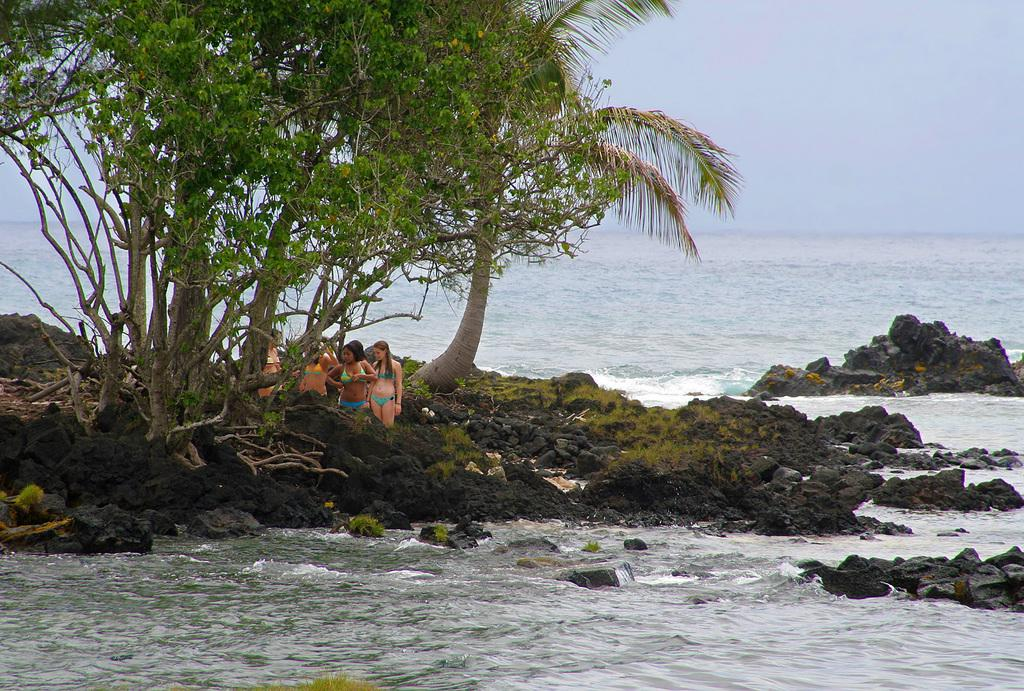What is the primary element visible in the image? There is water in the image. What other natural elements can be seen in the image? There are rocks and trees visible in the image. Are there any people present in the image? Yes, there is a group of people in the image. What is visible at the top of the image? The sky is visible at the top of the image. Can you tell me how many horses are in the image? There are no horses present in the image. What type of animal can be seen interacting with the people in the image? There are no animals visible in the image; only people, water, rocks, trees, and the sky are present. 